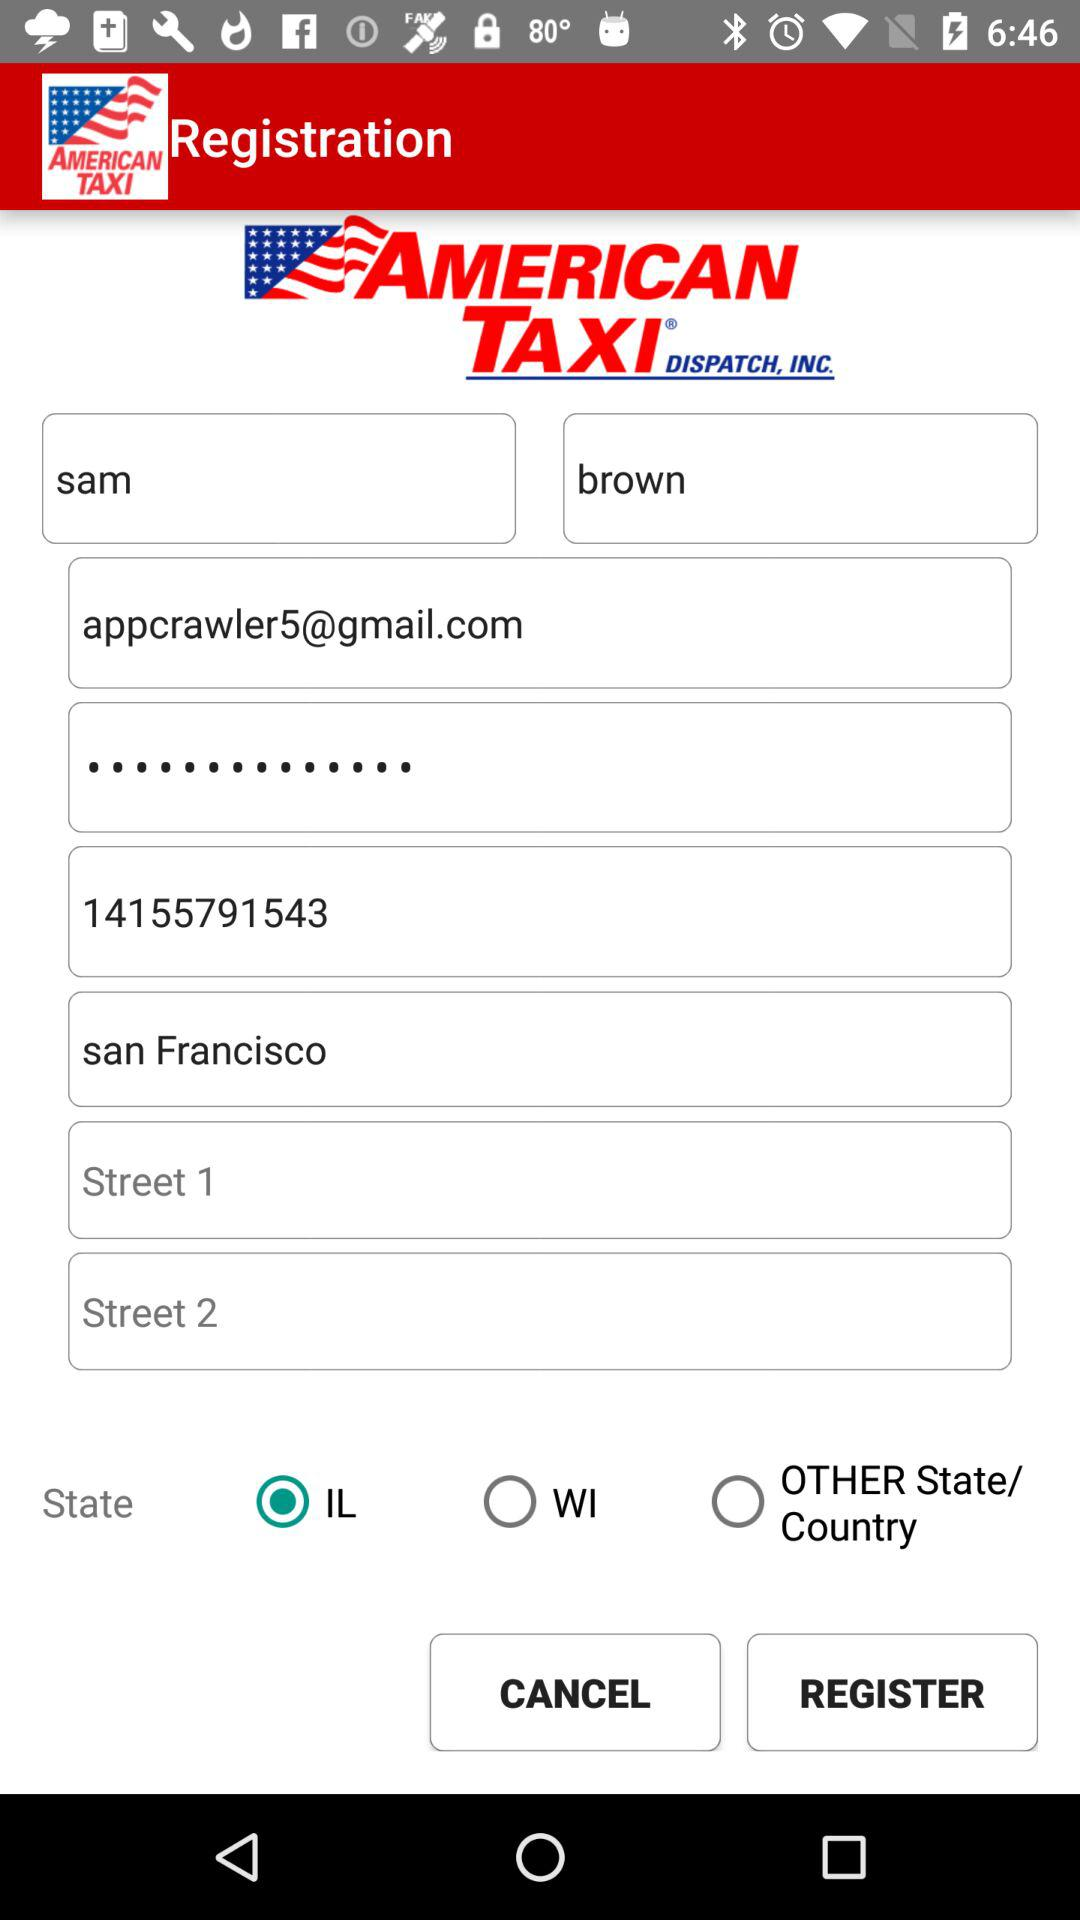What is the application name? The application name is "American Taxi Dispatch". 